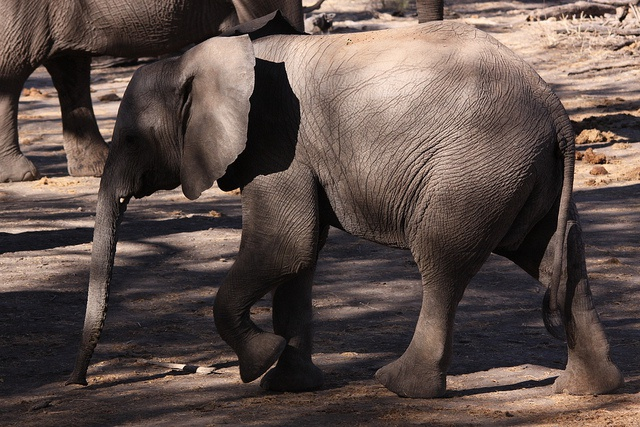Describe the objects in this image and their specific colors. I can see elephant in tan, black, gray, and darkgray tones and elephant in tan, black, and gray tones in this image. 